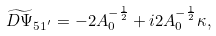<formula> <loc_0><loc_0><loc_500><loc_500>\widetilde { D \Psi } _ { 5 1 ^ { ^ { \prime } } } = - 2 A _ { 0 } ^ { - \frac { 1 } { 2 } } + i 2 A _ { 0 } ^ { - \frac { 1 } { 2 } } \kappa ,</formula> 